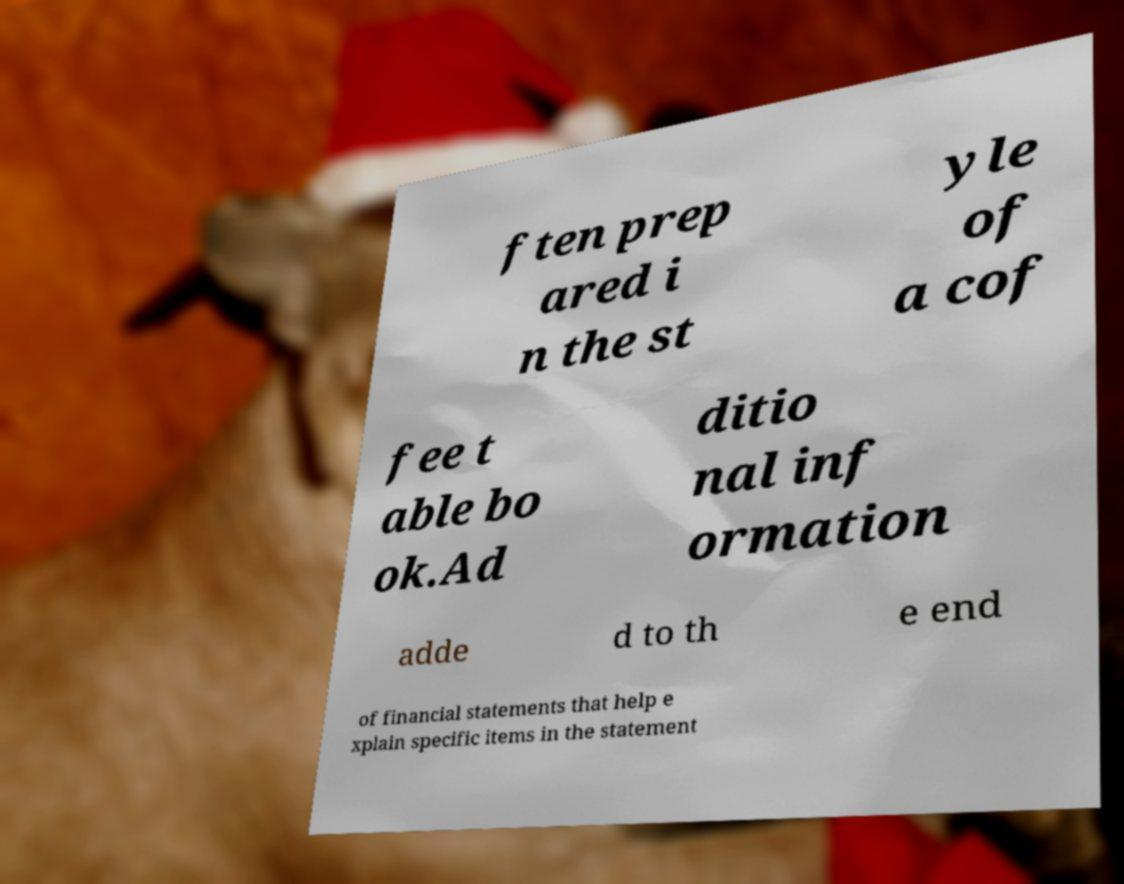Could you assist in decoding the text presented in this image and type it out clearly? ften prep ared i n the st yle of a cof fee t able bo ok.Ad ditio nal inf ormation adde d to th e end of financial statements that help e xplain specific items in the statement 